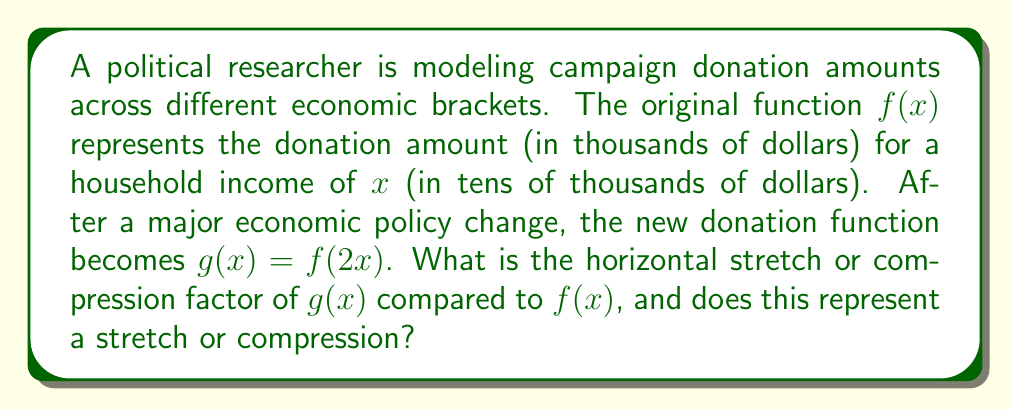Teach me how to tackle this problem. To determine the horizontal stretch or compression factor and whether it's a stretch or compression, we need to analyze the transformation from $f(x)$ to $g(x)$.

1) The general form of a horizontal transformation is:
   $g(x) = f(a(x-h))$, where $a$ is the stretch/compression factor and $h$ is the horizontal shift.

2) In our case, $g(x) = f(2x)$. Comparing this to the general form:
   $g(x) = f(2(x-0))$

3) We can identify that $a = 2$ and $h = 0$ (no horizontal shift).

4) The stretch/compression factor is $|a| = |2| = 2$.

5) To determine if it's a stretch or compression:
   - If $|a| > 1$, it's a horizontal compression.
   - If $0 < |a| < 1$, it's a horizontal stretch.

6) Since $|a| = 2$, which is greater than 1, this transformation represents a horizontal compression.

7) The compression factor is 2, meaning the graph of $g(x)$ is compressed horizontally by a factor of 2 compared to $f(x)$.

In the context of the problem, this means that after the economic policy change, the same donation amounts are reached at half the household income levels compared to before.
Answer: The horizontal transformation factor is 2, and it represents a compression. 